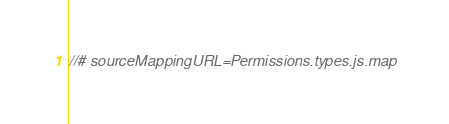Convert code to text. <code><loc_0><loc_0><loc_500><loc_500><_JavaScript_>//# sourceMappingURL=Permissions.types.js.map</code> 